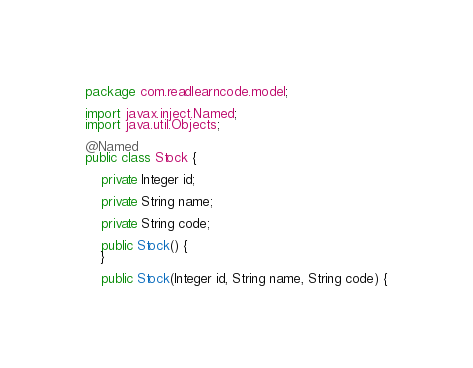<code> <loc_0><loc_0><loc_500><loc_500><_Java_>package com.readlearncode.model;

import javax.inject.Named;
import java.util.Objects;

@Named
public class Stock {

	private Integer id;

	private String name;

	private String code;

	public Stock() {
	}

	public Stock(Integer id, String name, String code) {</code> 